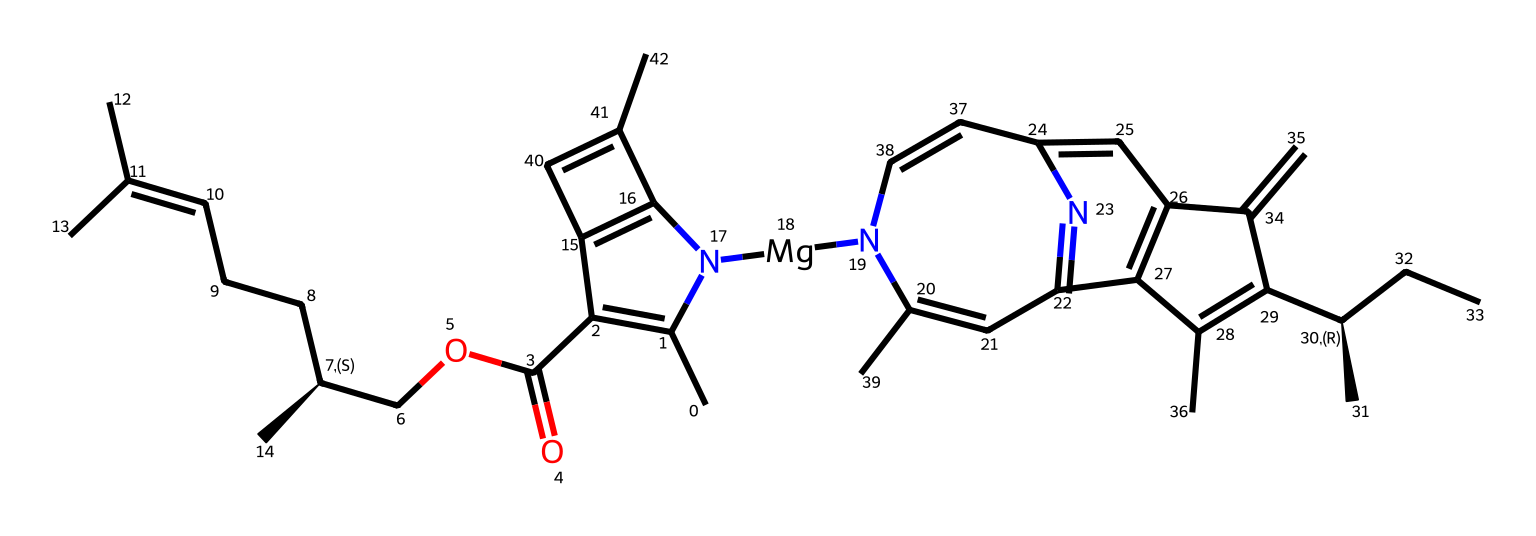What metal ion is present in the molecular structure of chlorophyll? The SMILES indicates the presence of a magnesium ion (Mg) in the coordination center as part of the macrocyclic structure characteristic of chlorophyll.
Answer: magnesium How many carbon atoms are in the chlorophyll structure? Analyzing the SMILES representation reveals a total of 21 carbon atoms present in the chemical structure of chlorophyll.
Answer: 21 What functional group is featured in the chlorophyll molecule? The structure contains an ester functional group (OC=O) as part of its architecture, which is linked to the cyclic structure.
Answer: ester What type of coordination compound is chlorophyll? Chlorophyll is classified as a metalloporphyrin because it contains a porphyrin-like structure coordinated with a metal ion, specifically magnesium.
Answer: metalloporphyrin How many nitrogen atoms are present in the chlorophyll structure? Reviewing the chemical structure, there are 4 nitrogen atoms found in the chlorophyll molecule contributing to its heterocyclic composition.
Answer: 4 What role does magnesium play in the chlorophyll molecule? The magnesium ion is central to the coordination complex, essential for the chlorophyll's ability to absorb light energy during photosynthesis.
Answer: light absorption What significance does chlorophyll have in photosynthesis? Chlorophyll is crucial for capturing light energy, which drives the photosynthesis process in plants, algae, and some bacteria.
Answer: light capture 